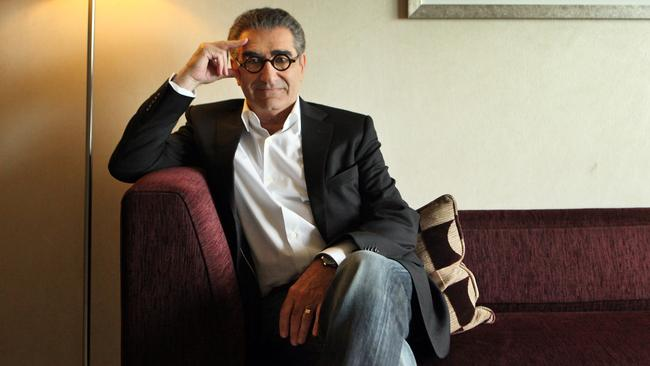How does the choice of clothing contribute to our perception of the individual? The blend of a formal black jacket and jeans suggests a versatile personality, blending professionalism with comfort. This attire suggests he maintains a poised appearance without sacrificing personal comfort, which might indicate his approachability and balanced nature. 